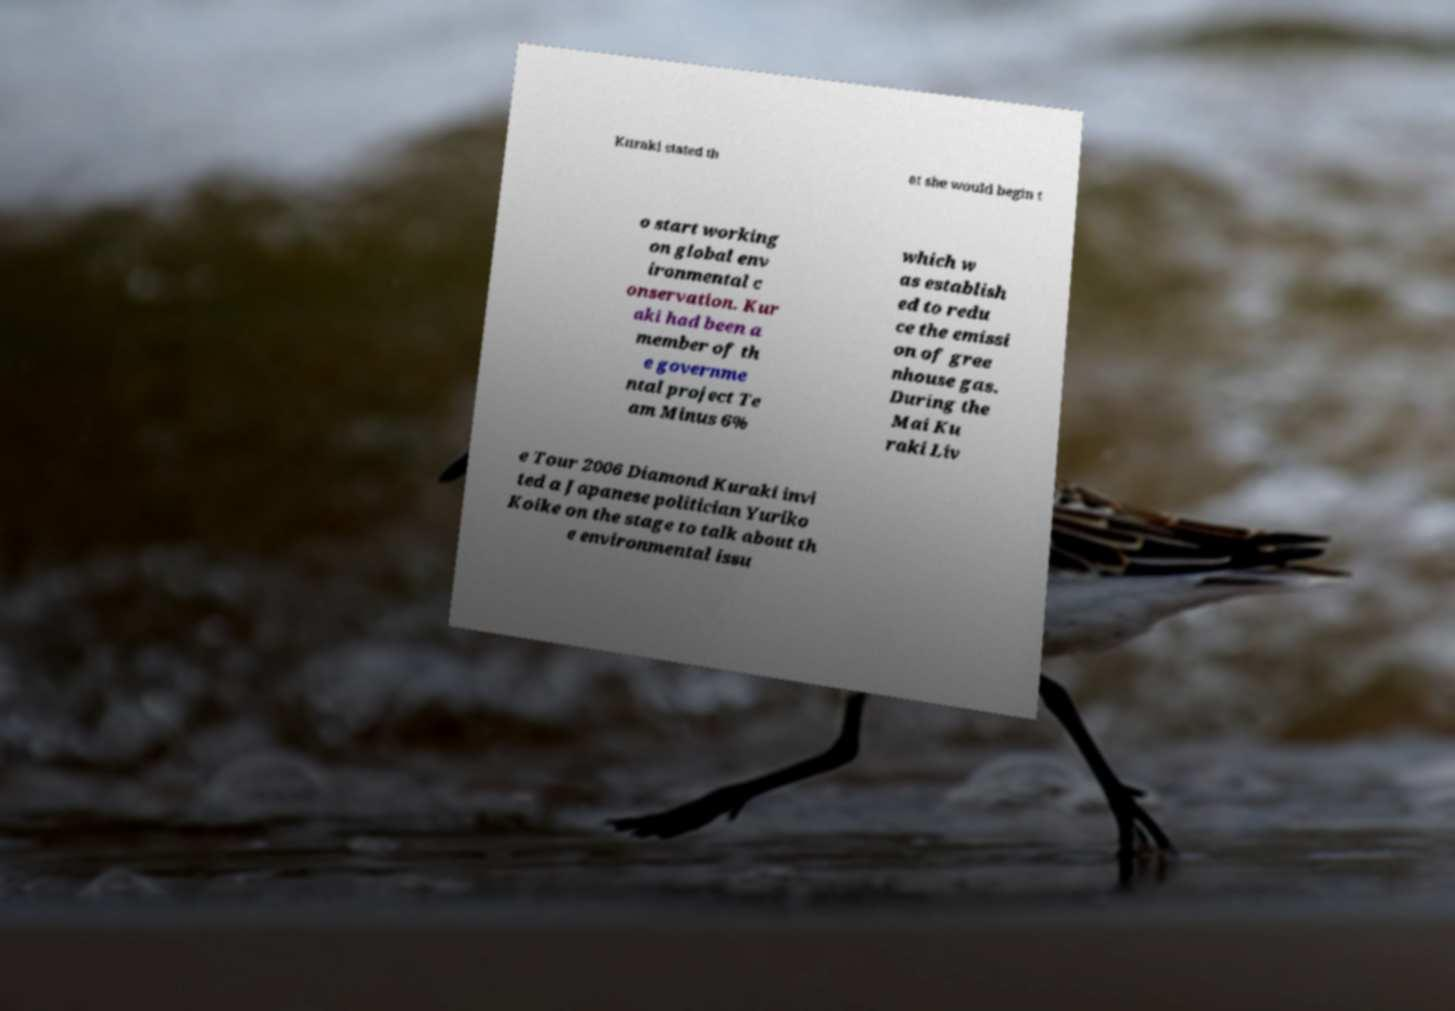What messages or text are displayed in this image? I need them in a readable, typed format. Kuraki stated th at she would begin t o start working on global env ironmental c onservation. Kur aki had been a member of th e governme ntal project Te am Minus 6% which w as establish ed to redu ce the emissi on of gree nhouse gas. During the Mai Ku raki Liv e Tour 2006 Diamond Kuraki invi ted a Japanese politician Yuriko Koike on the stage to talk about th e environmental issu 